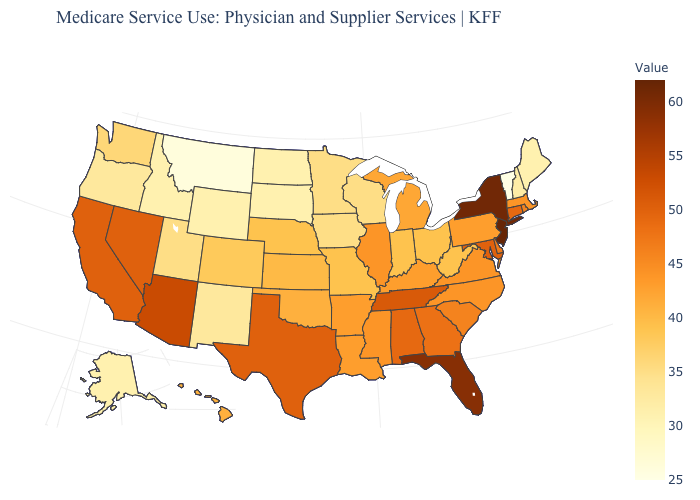Which states hav the highest value in the West?
Be succinct. Arizona. Does West Virginia have a lower value than Tennessee?
Give a very brief answer. Yes. Does North Carolina have a lower value than Maryland?
Write a very short answer. Yes. Which states hav the highest value in the Northeast?
Write a very short answer. New Jersey. Which states have the lowest value in the USA?
Answer briefly. Vermont. 